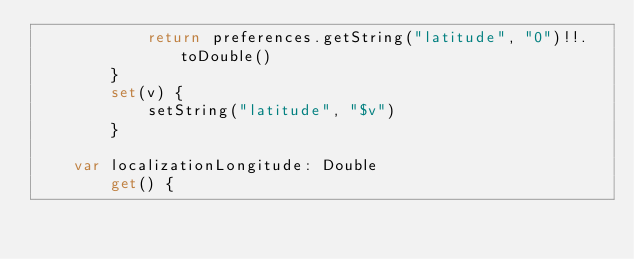Convert code to text. <code><loc_0><loc_0><loc_500><loc_500><_Kotlin_>            return preferences.getString("latitude", "0")!!.toDouble()
        }
        set(v) {
            setString("latitude", "$v")
        }

    var localizationLongitude: Double
        get() {</code> 